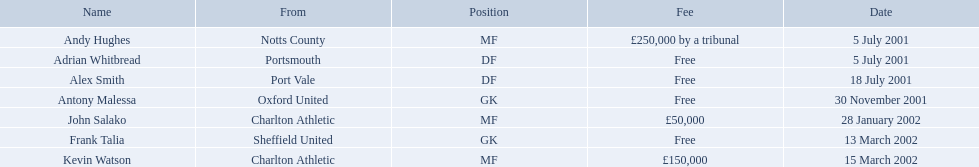Who are all the players? Andy Hughes, Adrian Whitbread, Alex Smith, Antony Malessa, John Salako, Frank Talia, Kevin Watson. What were their fees? £250,000 by a tribunal, Free, Free, Free, £50,000, Free, £150,000. And how much was kevin watson's fee? £150,000. List all the players names Andy Hughes, Adrian Whitbread, Alex Smith, Antony Malessa, John Salako, Frank Talia, Kevin Watson. Of these who is kevin watson Kevin Watson. To what transfer fee entry does kevin correspond to? £150,000. 